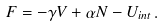Convert formula to latex. <formula><loc_0><loc_0><loc_500><loc_500>F = - \gamma V + \alpha N - U _ { i n t } \, .</formula> 